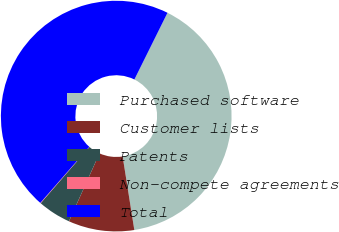Convert chart to OTSL. <chart><loc_0><loc_0><loc_500><loc_500><pie_chart><fcel>Purchased software<fcel>Customer lists<fcel>Patents<fcel>Non-compete agreements<fcel>Total<nl><fcel>40.16%<fcel>9.23%<fcel>4.65%<fcel>0.07%<fcel>45.89%<nl></chart> 